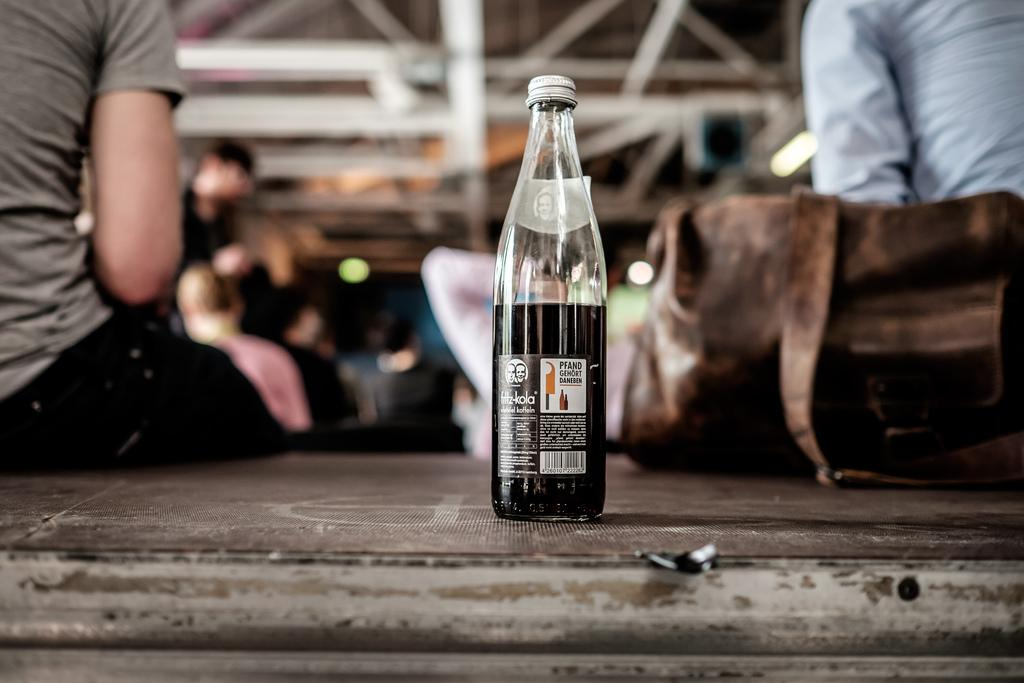What object can be seen in the image? There is a bottle in the image. What are the people in the image doing? There are persons sitting on the floor in the image. What color is the handbag in the image? There is a handbag in brown color in the image. Can you describe the background of the image? The background of the image is blurred. How many taxes are being paid by the persons sitting on the floor in the image? There is no mention of taxes in the image, and the persons sitting on the floor are not engaged in any activity related to paying taxes. What type of quiver is visible in the image? There is no quiver present in the image. 